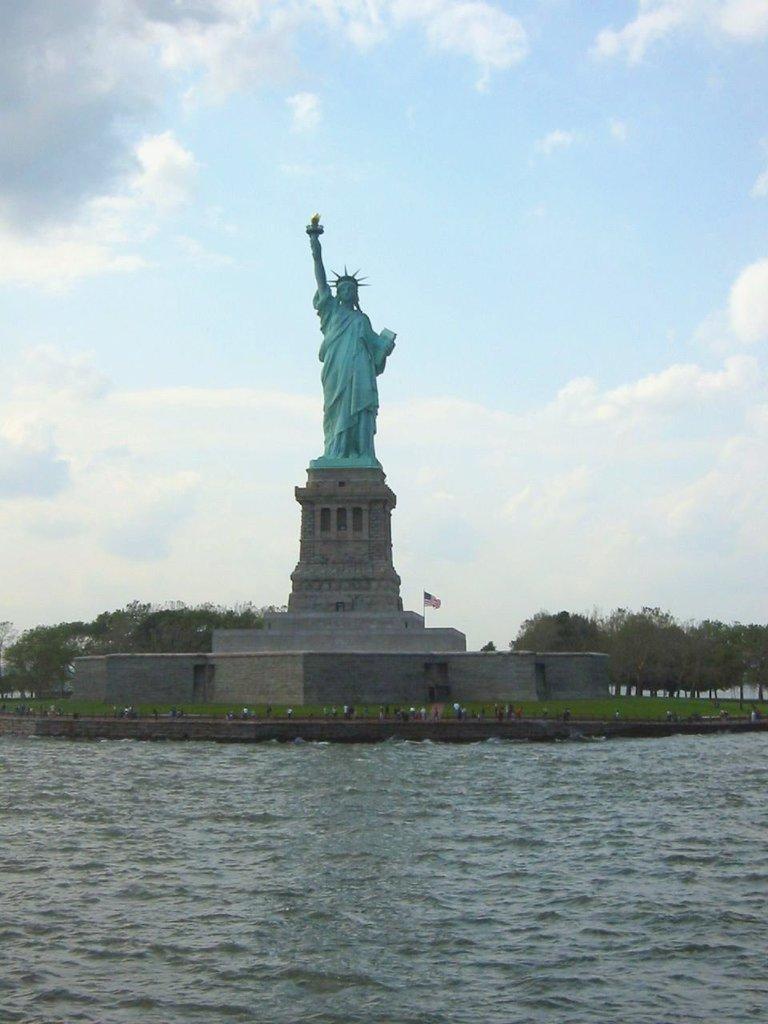Please provide a concise description of this image. In this image there is a statue of liberty in the middle. At the bottom there is water. In the background there are trees. At the top there is sky. 